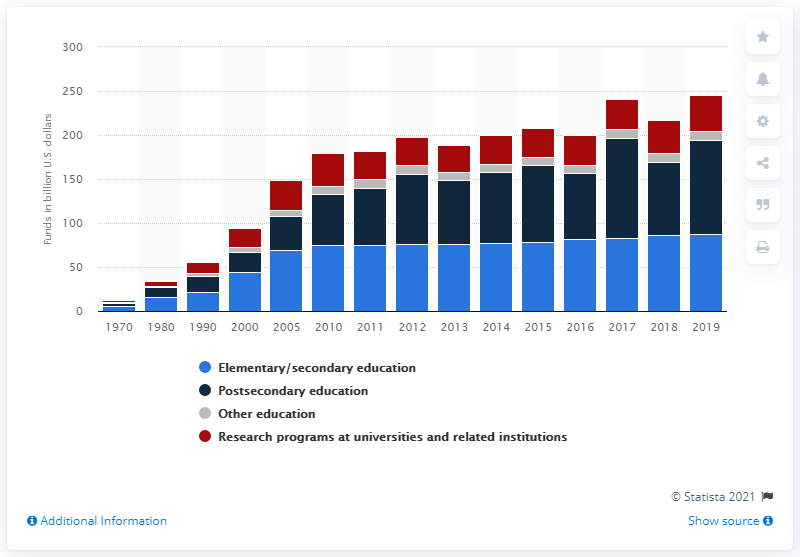Identify some key points in this picture. The federal government spent $107.47 billion on postsecondary education programs in the United States in 2019. 